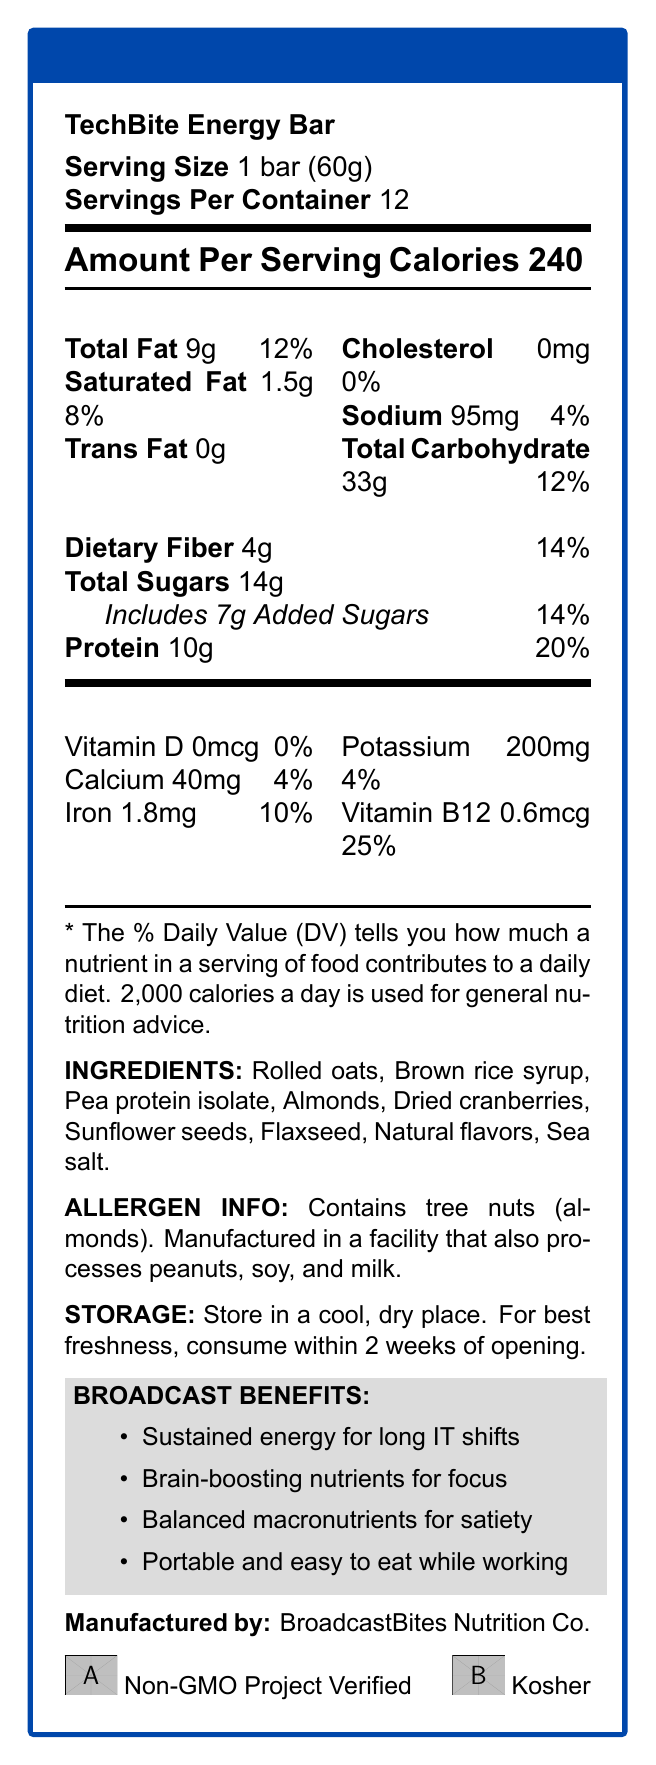what is the serving size of the TechBite Energy Bar? The serving size is stated directly under the product name as "1 bar (60g)".
Answer: 1 bar (60g) how many bars are there per container? The number of servings per container is stated as 12.
Answer: 12 how many calories are in one serving of the TechBite Energy Bar? The document states the calorie count as "Calories 240" under the Amount Per Serving section.
Answer: 240 what percentage of daily value is the protein in one serving? The protein content's percentage of daily value is listed as 20%.
Answer: 20% does the TechBite Energy Bar contain cholesterol? The label shows "Cholesterol 0mg 0%", indicating it contains no cholesterol.
Answer: No how much saturated fat is in one serving? Under the Total Fat section, saturated fat content is listed as "1.5g 8%".
Answer: 1.5g is the TechBite Energy Bar suitable for people with nut allergies? The allergen information states it contains tree nuts (almonds) and is manufactured in a facility that processes peanuts, soy, and milk.
Answer: No which of the following nutrients does the TechBite Energy Bar have the highest daily value percentage? A. Sodium B. Iron C. Dietary Fiber D. Vitamin B12 The content list shows Vitamin B12 with a daily value percentage of 25%.
Answer: D. Vitamin B12 how much added sugar does the TechBite Energy Bar have? A. 5g B. 7g C. 9g D. 14g The document states "Includes 7g Added Sugars".
Answer: B. 7g does this product provide any Vitamin D? The nutrition facts indicate "Vitamin D 0mcg 0%," meaning there is no Vitamin D.
Answer: No summarize the benefits of the TechBite Energy Bar mentioned in the document. The Broadcast Benefits section lists the sustained energy, brain-boosting nutrients, balanced macronutrients, and portability as the key advantages for this product.
Answer: The TechBite Energy Bar is designed to offer sustained energy, brain-boosting nutrients, balanced macronutrients for satiety, and is portable and easy to eat. These benefits make it suitable for IT professionals working in long shifts. who is the manufacturer of the TechBite Energy Bar? The document mentions the manufacturer as BroadcastBites Nutrition Co.
Answer: BroadcastBites Nutrition Co. how much total fat is in one serving? Total fat content is listed as "Total Fat 9g 12%" under the Amount Per Serving.
Answer: 9g what certifications does the TechBite Energy Bar have? At the bottom of the document, it lists these certifications with corresponding icons.
Answer: Non-GMO Project Verified, Kosher how many grams of dietary fiber are in one serving? Dietary fiber is listed as 4g, with a daily value percentage of 14%.
Answer: 4g how should the TechBite Energy Bar be stored? The document's storage instructions specify keeping the bar in a cool, dry place and consuming it within 2 weeks of opening for best freshness.
Answer: Store in a cool, dry place. For best freshness, consume within 2 weeks of opening. what is not included in the ingredient list? Without further information, it is not possible to ascertain what ingredients are not included from the document.
Answer: Cannot be determined does the TechBite Energy Bar contain any allergens? The allergen information specifies it contains tree nuts (almonds) and may also be exposed to peanuts, soy, and milk during manufacturing.
Answer: Yes 